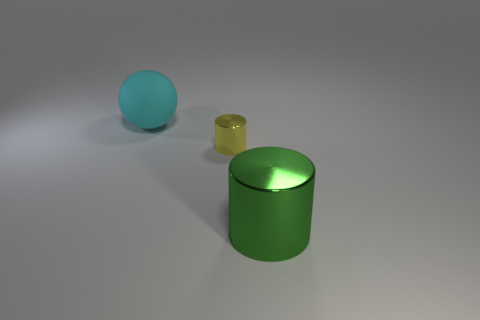There is a big thing to the right of the big matte object; is there a big cyan matte object that is in front of it?
Make the answer very short. No. Do the metal cylinder behind the green metallic thing and the rubber object have the same size?
Offer a very short reply. No. The cyan matte thing has what size?
Keep it short and to the point. Large. Are there any other things of the same color as the large metallic thing?
Provide a short and direct response. No. How many tiny objects are green objects or red shiny blocks?
Offer a terse response. 0. There is a tiny yellow cylinder; what number of tiny yellow metallic things are to the right of it?
Give a very brief answer. 0. What number of spheres are either large shiny things or large cyan things?
Keep it short and to the point. 1. Is the number of things that are behind the small yellow cylinder less than the number of small rubber cubes?
Your answer should be very brief. No. What is the color of the thing that is to the right of the ball and behind the green metal cylinder?
Ensure brevity in your answer.  Yellow. How many other objects are the same shape as the tiny yellow metallic object?
Provide a short and direct response. 1. 